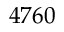<formula> <loc_0><loc_0><loc_500><loc_500>4 7 6 0</formula> 